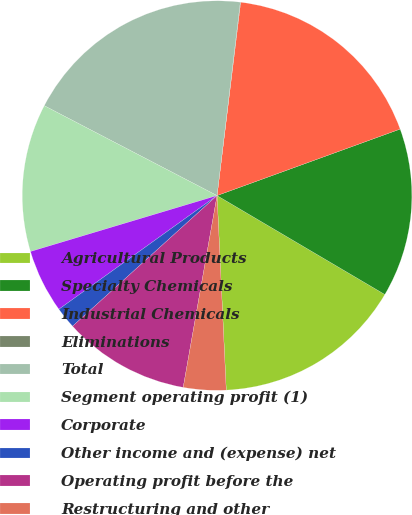Convert chart. <chart><loc_0><loc_0><loc_500><loc_500><pie_chart><fcel>Agricultural Products<fcel>Specialty Chemicals<fcel>Industrial Chemicals<fcel>Eliminations<fcel>Total<fcel>Segment operating profit (1)<fcel>Corporate<fcel>Other income and (expense) net<fcel>Operating profit before the<fcel>Restructuring and other<nl><fcel>15.77%<fcel>14.02%<fcel>17.52%<fcel>0.03%<fcel>19.27%<fcel>12.27%<fcel>5.28%<fcel>1.78%<fcel>10.52%<fcel>3.53%<nl></chart> 